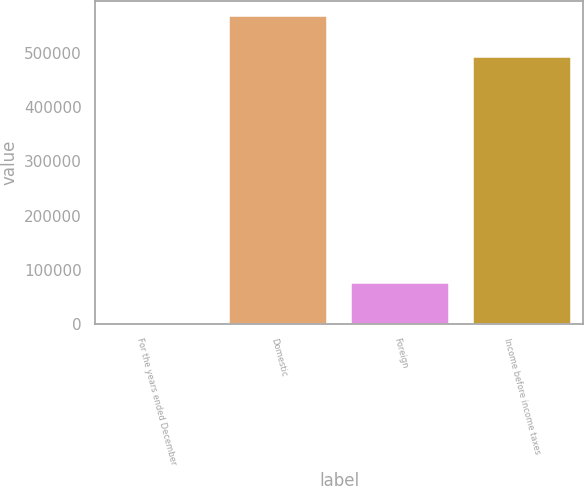<chart> <loc_0><loc_0><loc_500><loc_500><bar_chart><fcel>For the years ended December<fcel>Domestic<fcel>Foreign<fcel>Income before income taxes<nl><fcel>2008<fcel>568282<fcel>76260<fcel>492022<nl></chart> 